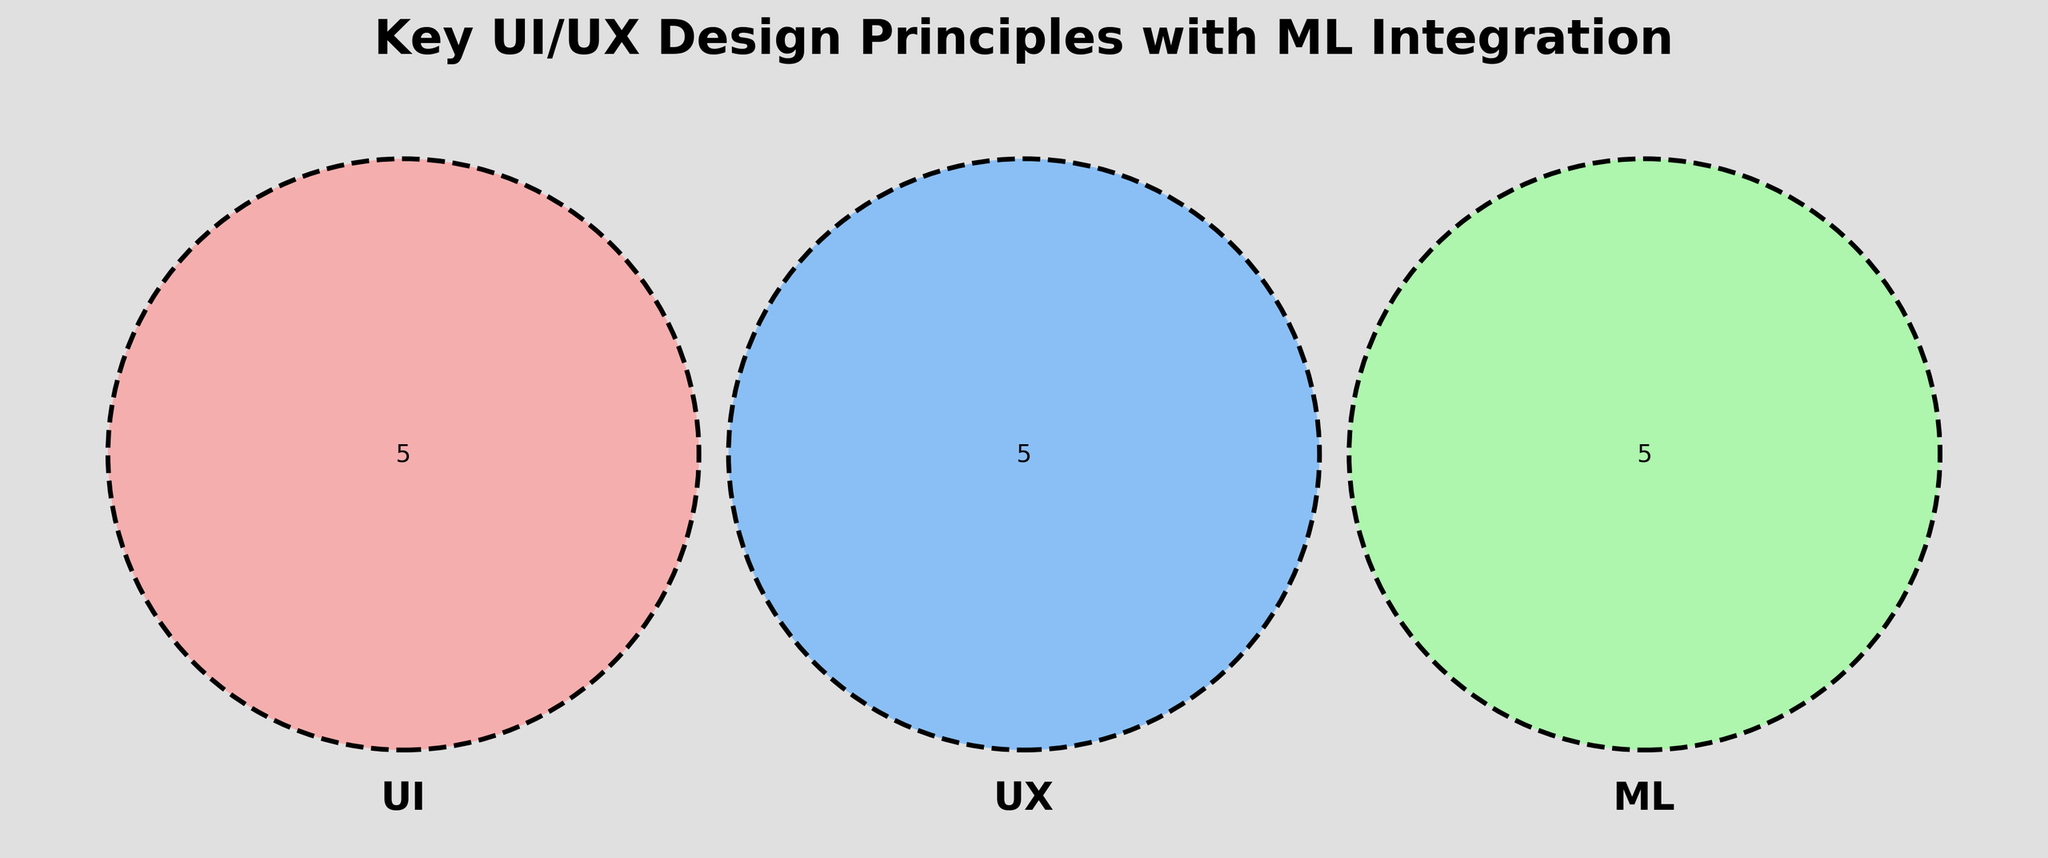What are the three circles labeled as? The three circles are labeled with the names of the different categories represented in the Venn Diagram. The labels can be read directly from the figure.
Answer: UI, UX, ML Which principle is common to both UI and UX but not ML? To find the principle that is common to both UI and UX but not ML, look at the intersection section where only UI and UX overlap and ML doesn't.
Answer: Learnability How many principles belong exclusively to the UX category? To determine the number of principles exclusively in the UX category, check the area of the circle labeled UX that does not overlap with the other circles.
Answer: 1 Which principle is shared among all three categories? To identify the principle that is shared among UI, UX, and ML, look at the overlapping region of the three circles in the Venn Diagram.
Answer: There is no common principle shared among all three categories Are there more principles in the UI+ML intersection or in the UX+ML intersection? Compare the number of principles in the intersection of UI and ML with those in the intersection of UX and ML by inspecting each overlapping region and counting the principles.
Answer: UI+ML intersection What is the color used to represent the ML circle? Identify the color of the circle labeled ML by examining the Venn Diagram and describing the color seen.
Answer: Green Is "Visual Hierarchy" part of the UI category? Look at the segment of the Venn Diagram that represents the UI circle and check if "Visual Hierarchy" is listed there.
Answer: Yes 